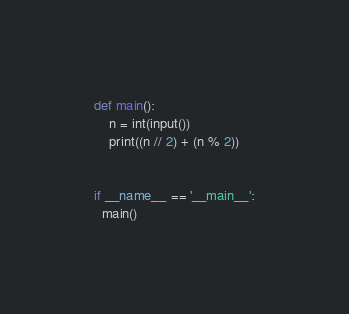<code> <loc_0><loc_0><loc_500><loc_500><_Python_>def main():
    n = int(input())
    print((n // 2) + (n % 2))
      

if __name__ == '__main__':
  main()</code> 